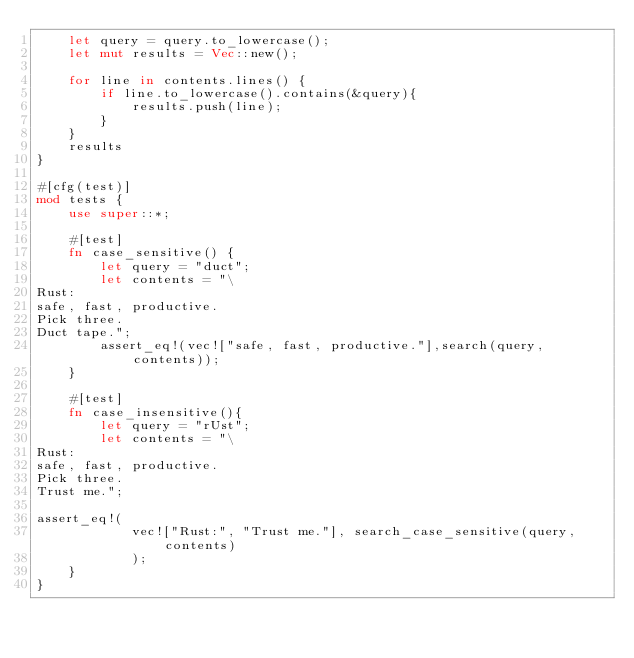Convert code to text. <code><loc_0><loc_0><loc_500><loc_500><_Rust_>    let query = query.to_lowercase();
    let mut results = Vec::new();

    for line in contents.lines() {
        if line.to_lowercase().contains(&query){
            results.push(line);
        }
    }
    results
}

#[cfg(test)]
mod tests {
    use super::*;

    #[test]
    fn case_sensitive() {
        let query = "duct";
        let contents = "\
Rust:
safe, fast, productive.
Pick three.
Duct tape.";
        assert_eq!(vec!["safe, fast, productive."],search(query, contents));
    }  

    #[test]
    fn case_insensitive(){
        let query = "rUst";
        let contents = "\
Rust:
safe, fast, productive.
Pick three.
Trust me.";

assert_eq!(
            vec!["Rust:", "Trust me."], search_case_sensitive(query, contents)
            );
    }
}
</code> 